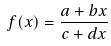Convert formula to latex. <formula><loc_0><loc_0><loc_500><loc_500>f ( x ) = \frac { a + b x } { c + d x }</formula> 